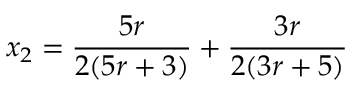Convert formula to latex. <formula><loc_0><loc_0><loc_500><loc_500>x _ { 2 } = \frac { 5 r } { 2 ( 5 r + 3 ) } + \frac { 3 r } { 2 ( 3 r + 5 ) }</formula> 